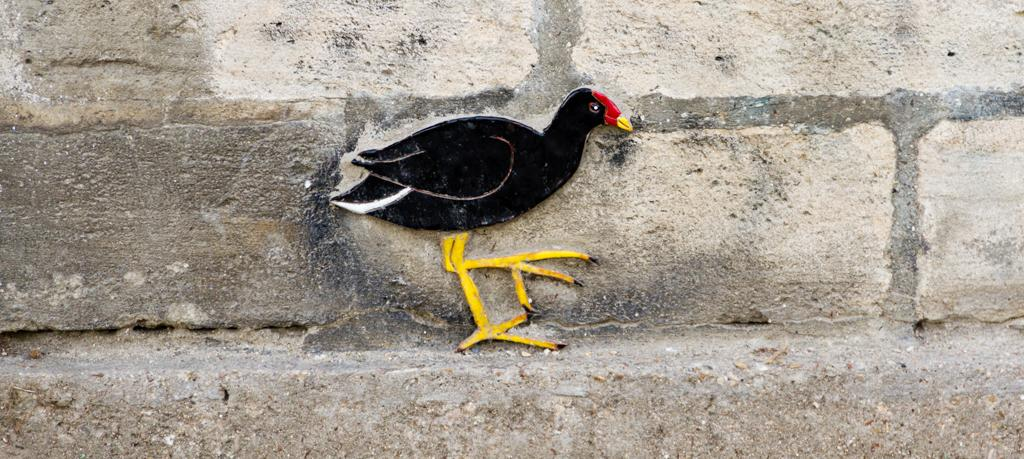What is present on the wall in the image? There is a picture of a bird on the wall. What color is the picture of the bird? The picture of the bird is in black color. How many apples are hanging from the bird's beak in the image? There are no apples present in the image, nor are they hanging from the bird's beak. 